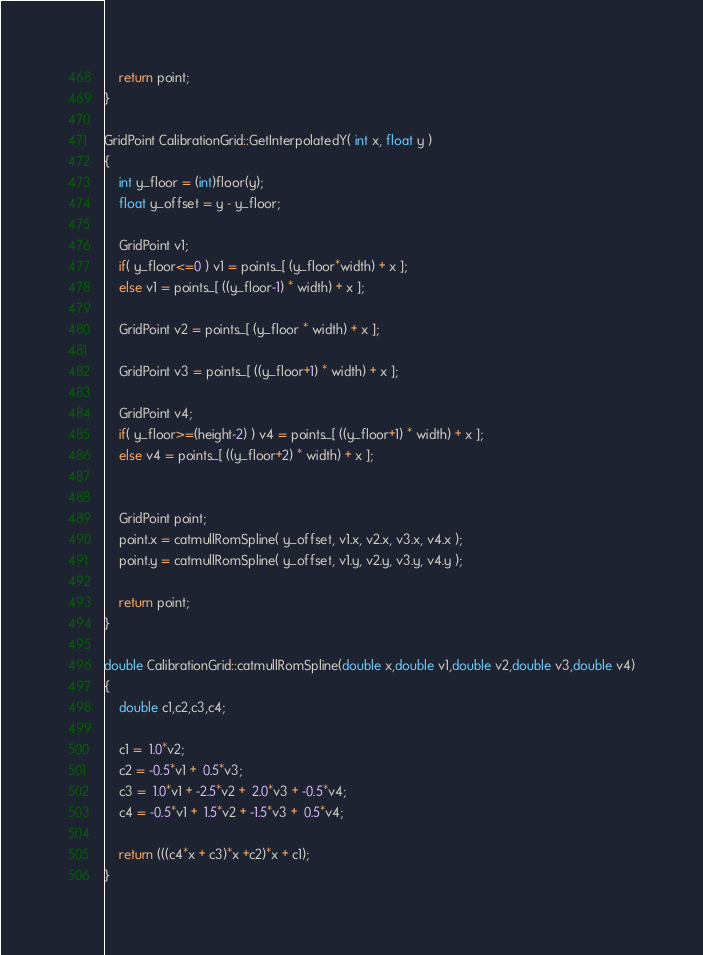Convert code to text. <code><loc_0><loc_0><loc_500><loc_500><_C++_>
	return point;
}

GridPoint CalibrationGrid::GetInterpolatedY( int x, float y )
{
	int y_floor = (int)floor(y);
	float y_offset = y - y_floor;

	GridPoint v1;
	if( y_floor<=0 ) v1 = points_[ (y_floor*width) + x ];
	else v1 = points_[ ((y_floor-1) * width) + x ];

	GridPoint v2 = points_[ (y_floor * width) + x ];

	GridPoint v3 = points_[ ((y_floor+1) * width) + x ];

	GridPoint v4;
	if( y_floor>=(height-2) ) v4 = points_[ ((y_floor+1) * width) + x ];
	else v4 = points_[ ((y_floor+2) * width) + x ];


	GridPoint point;
	point.x = catmullRomSpline( y_offset, v1.x, v2.x, v3.x, v4.x );
	point.y = catmullRomSpline( y_offset, v1.y, v2.y, v3.y, v4.y );

	return point;
}

double CalibrationGrid::catmullRomSpline(double x,double v1,double v2,double v3,double v4)
{
	double c1,c2,c3,c4;

	c1 =  1.0*v2;
	c2 = -0.5*v1 +  0.5*v3;
	c3 =  1.0*v1 + -2.5*v2 +  2.0*v3 + -0.5*v4;
	c4 = -0.5*v1 +  1.5*v2 + -1.5*v3 +  0.5*v4;

	return (((c4*x + c3)*x +c2)*x + c1);
}
</code> 